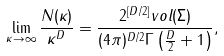Convert formula to latex. <formula><loc_0><loc_0><loc_500><loc_500>\lim _ { \kappa \to \infty } \frac { N ( \kappa ) } { \kappa ^ { D } } = \frac { 2 ^ { [ D / 2 ] } v o l ( \Sigma ) } { ( 4 \pi ) ^ { D / 2 } \Gamma \left ( \frac { D } { 2 } + 1 \right ) } ,</formula> 